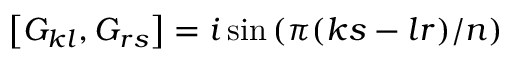Convert formula to latex. <formula><loc_0><loc_0><loc_500><loc_500>\left [ G _ { k l } , G _ { r s } \right ] = i \sin \left ( \pi ( k s - l r ) / n \right )</formula> 